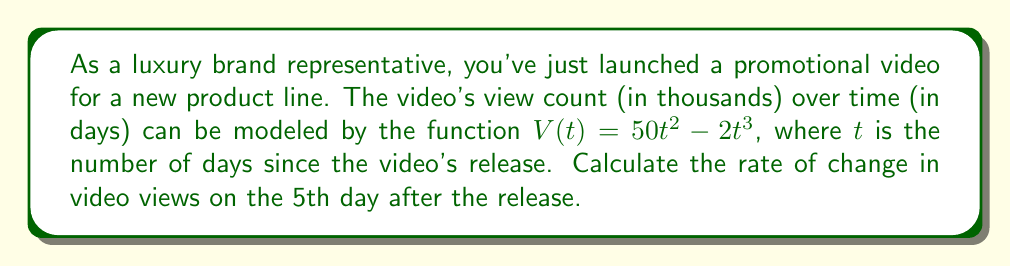Can you solve this math problem? To solve this problem, we need to find the derivative of the given function and then evaluate it at $t = 5$. Here's the step-by-step process:

1) The given function is:
   $V(t) = 50t^2 - 2t^3$

2) To find the rate of change, we need to calculate $\frac{dV}{dt}$:
   $$\frac{dV}{dt} = \frac{d}{dt}(50t^2 - 2t^3)$$

3) Using the power rule of differentiation:
   $$\frac{dV}{dt} = 50 \cdot 2t^{2-1} - 2 \cdot 3t^{3-1}$$
   $$\frac{dV}{dt} = 100t - 6t^2$$

4) This derivative represents the instantaneous rate of change in video views at any time $t$.

5) To find the rate of change on the 5th day, we substitute $t = 5$ into our derivative:
   $$\frac{dV}{dt}\bigg|_{t=5} = 100(5) - 6(5^2)$$
   $$= 500 - 6(25)$$
   $$= 500 - 150$$
   $$= 350$$

6) The units of this result are thousands of views per day, as the original function was in thousands of views.
Answer: The rate of change in video views on the 5th day after the release is 350,000 views per day. 